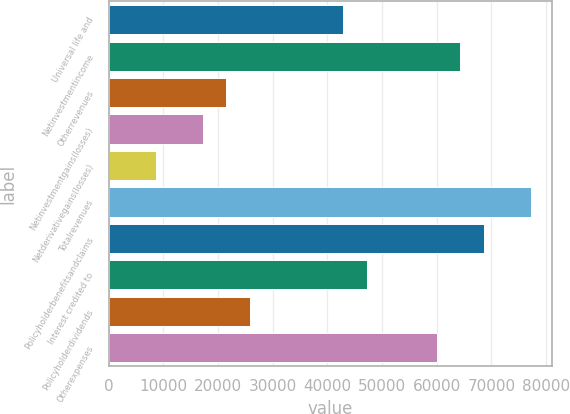<chart> <loc_0><loc_0><loc_500><loc_500><bar_chart><fcel>Universal life and<fcel>Netinvestmentincome<fcel>Otherrevenues<fcel>Netinvestmentgains(losses)<fcel>Netderivativegains(losses)<fcel>Totalrevenues<fcel>Policyholderbenefitsandclaims<fcel>Interest credited to<fcel>Policyholderdividends<fcel>Otherexpenses<nl><fcel>42921<fcel>64314.5<fcel>21527.5<fcel>17248.8<fcel>8691.4<fcel>77150.6<fcel>68593.2<fcel>47199.7<fcel>25806.2<fcel>60035.8<nl></chart> 